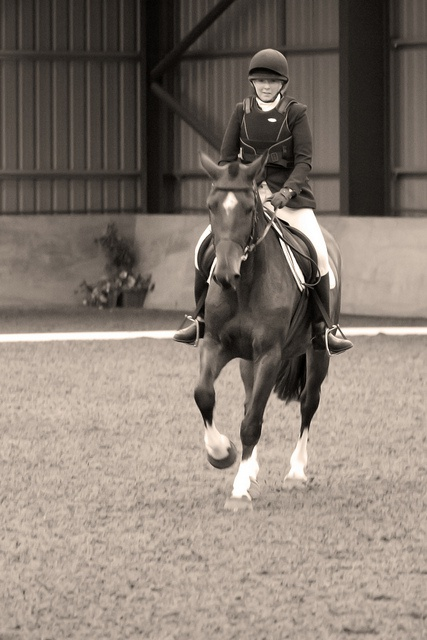Describe the objects in this image and their specific colors. I can see horse in black, gray, white, and darkgray tones, people in black, gray, white, and darkgray tones, and potted plant in black and gray tones in this image. 